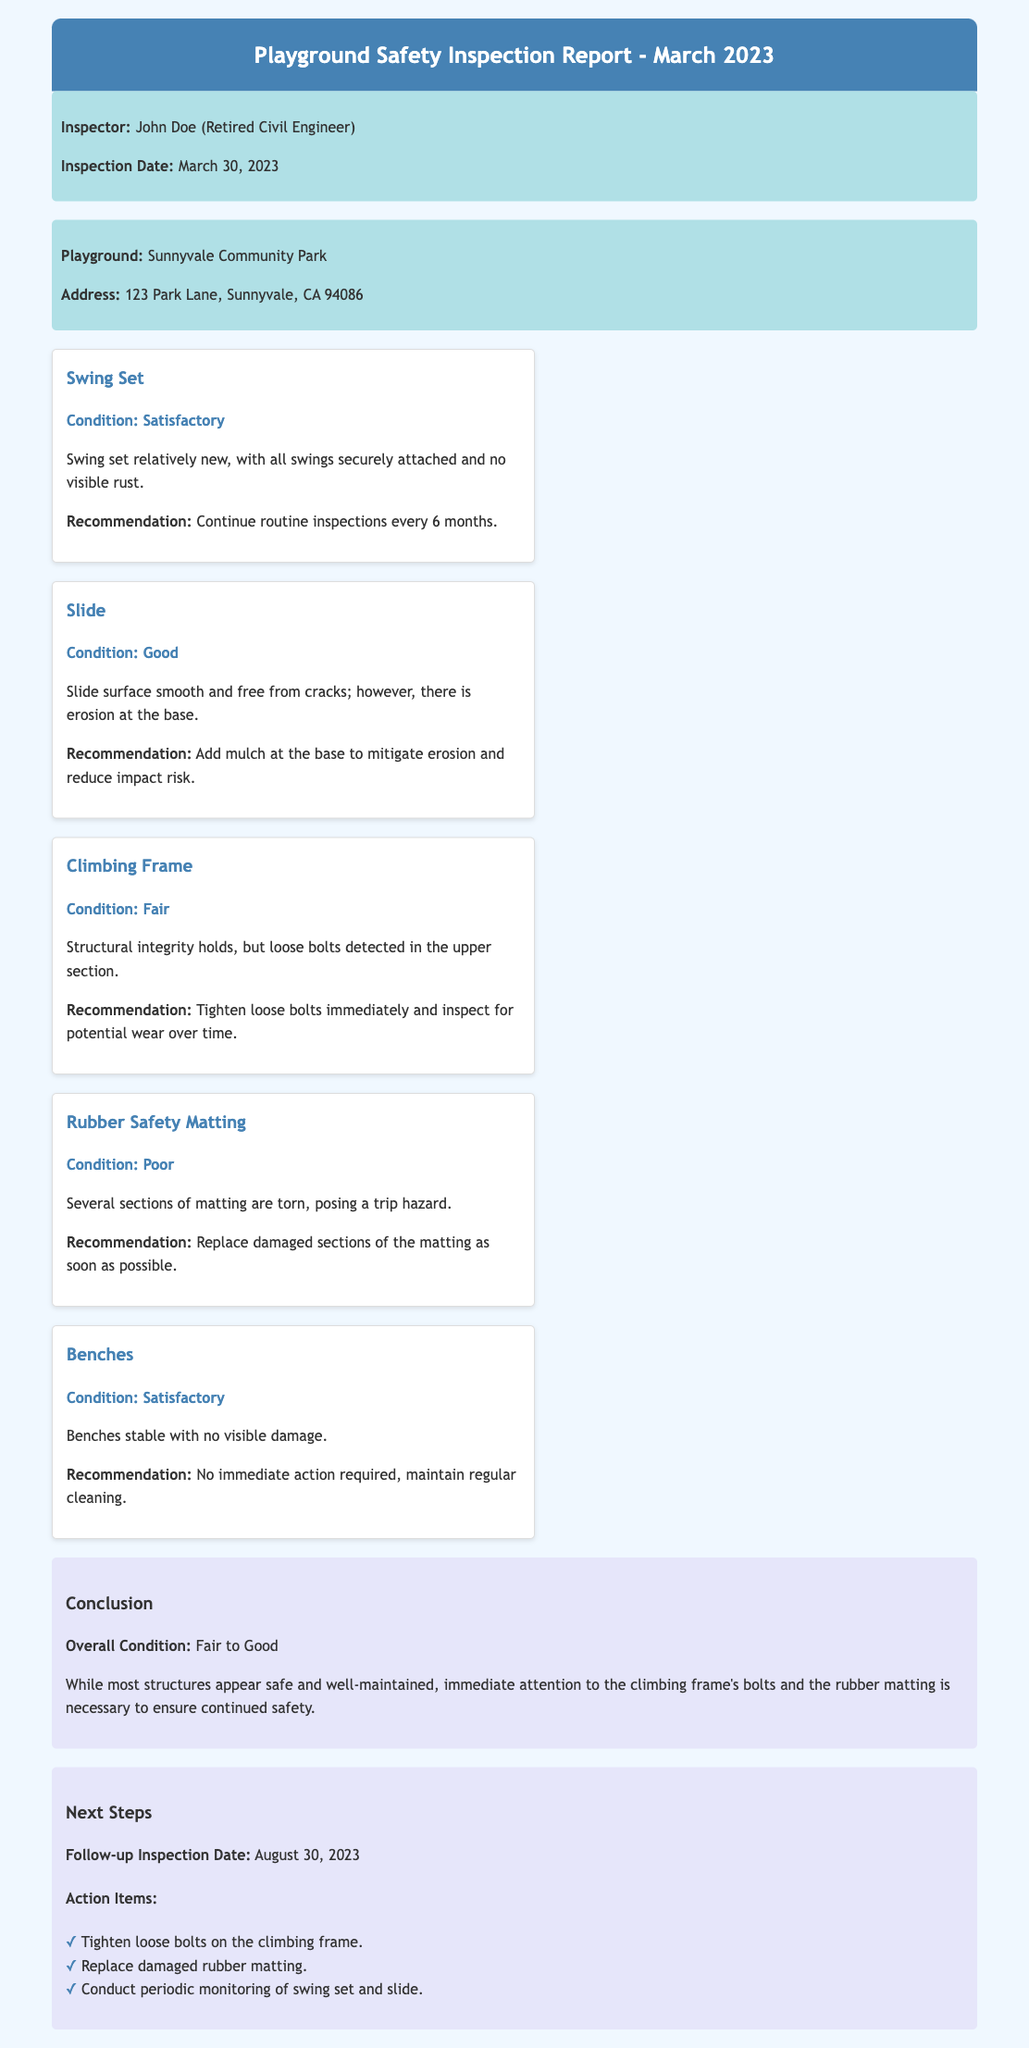What is the name of the inspector? The inspector's name is mentioned in the inspector info section, which states "John Doe."
Answer: John Doe What is the inspection date? The inspection date can be found in the inspector info section of the document, listed as "March 30, 2023."
Answer: March 30, 2023 What is the condition of the Swing Set? The condition of the Swing Set is mentioned in the findings section, labeled as "Satisfactory."
Answer: Satisfactory How many action items are listed under Next Steps? The number of action items can be identified from the list provided in the next steps section, which contains three items.
Answer: Three What is the condition of the Rubber Safety Matting? The condition of the Rubber Safety Matting is specified in the findings section and is stated as "Poor."
Answer: Poor What is the recommendation for the Slide? The recommendation for the Slide is included in the findings section and advises to "Add mulch at the base to mitigate erosion and reduce impact risk."
Answer: Add mulch at the base What are the next steps for the climbing frame? The next steps for the climbing frame are a specific action item listed under Next Steps, which states to "Tighten loose bolts on the climbing frame."
Answer: Tighten loose bolts What is the overall condition of the playground assessed in March 2023? The overall condition of the playground is detailed in the conclusion section and is described as "Fair to Good."
Answer: Fair to Good When is the follow-up inspection date? The follow-up inspection date is noted in the next steps section, which states "August 30, 2023."
Answer: August 30, 2023 